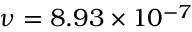<formula> <loc_0><loc_0><loc_500><loc_500>\nu = 8 . 9 3 \times 1 0 ^ { - 7 }</formula> 